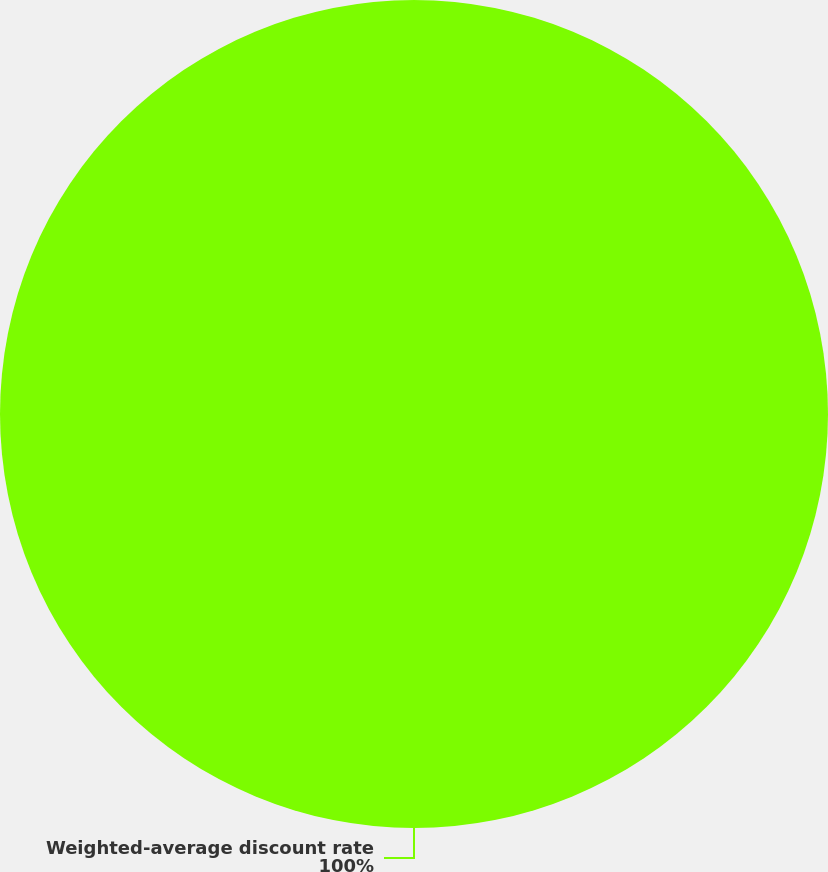Convert chart to OTSL. <chart><loc_0><loc_0><loc_500><loc_500><pie_chart><fcel>Weighted-average discount rate<nl><fcel>100.0%<nl></chart> 